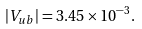<formula> <loc_0><loc_0><loc_500><loc_500>| V _ { u b } | = 3 . 4 5 \times 1 0 ^ { - 3 } .</formula> 